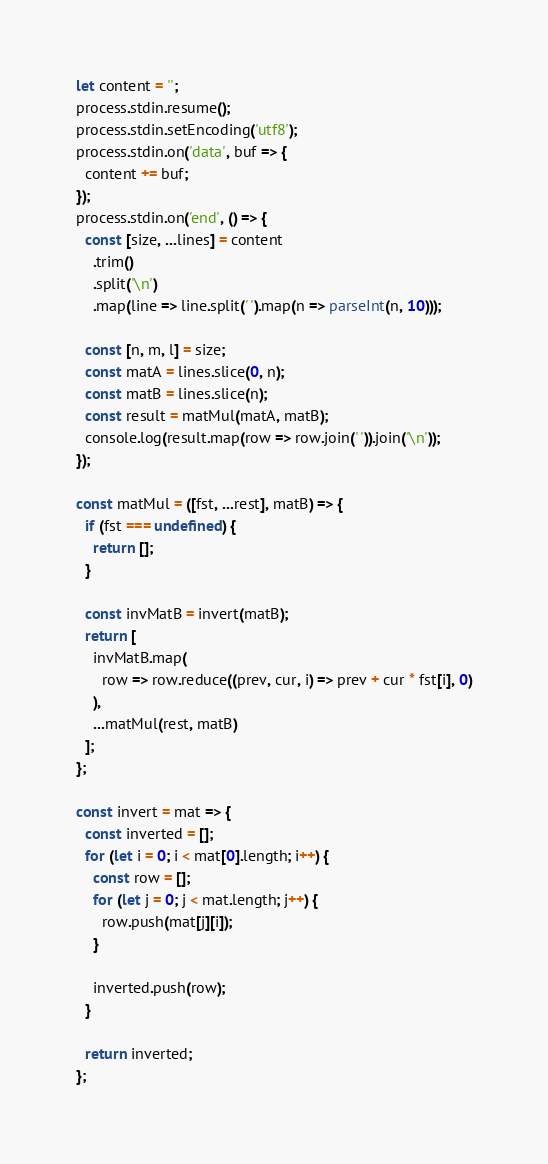<code> <loc_0><loc_0><loc_500><loc_500><_JavaScript_>let content = '';
process.stdin.resume();
process.stdin.setEncoding('utf8');
process.stdin.on('data', buf => {
  content += buf;
});
process.stdin.on('end', () => {
  const [size, ...lines] = content
    .trim()
    .split('\n')
    .map(line => line.split(' ').map(n => parseInt(n, 10)));
  
  const [n, m, l] = size;
  const matA = lines.slice(0, n);
  const matB = lines.slice(n);
  const result = matMul(matA, matB);
  console.log(result.map(row => row.join(' ')).join('\n'));
});

const matMul = ([fst, ...rest], matB) => {
  if (fst === undefined) {
    return [];
  }

  const invMatB = invert(matB);
  return [
    invMatB.map(
      row => row.reduce((prev, cur, i) => prev + cur * fst[i], 0)
    ),
    ...matMul(rest, matB)
  ];
};

const invert = mat => {
  const inverted = [];
  for (let i = 0; i < mat[0].length; i++) {
    const row = [];
    for (let j = 0; j < mat.length; j++) {
      row.push(mat[j][i]);
    }

    inverted.push(row);
  }

  return inverted;
};

</code> 